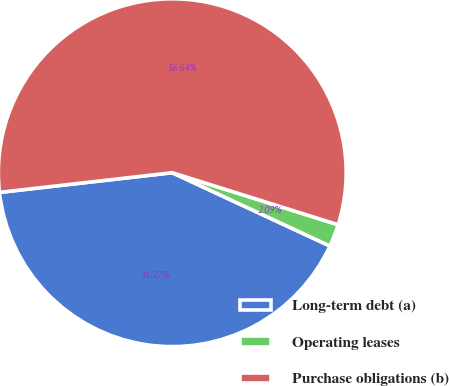Convert chart to OTSL. <chart><loc_0><loc_0><loc_500><loc_500><pie_chart><fcel>Long-term debt (a)<fcel>Operating leases<fcel>Purchase obligations (b)<nl><fcel>41.27%<fcel>2.09%<fcel>56.65%<nl></chart> 